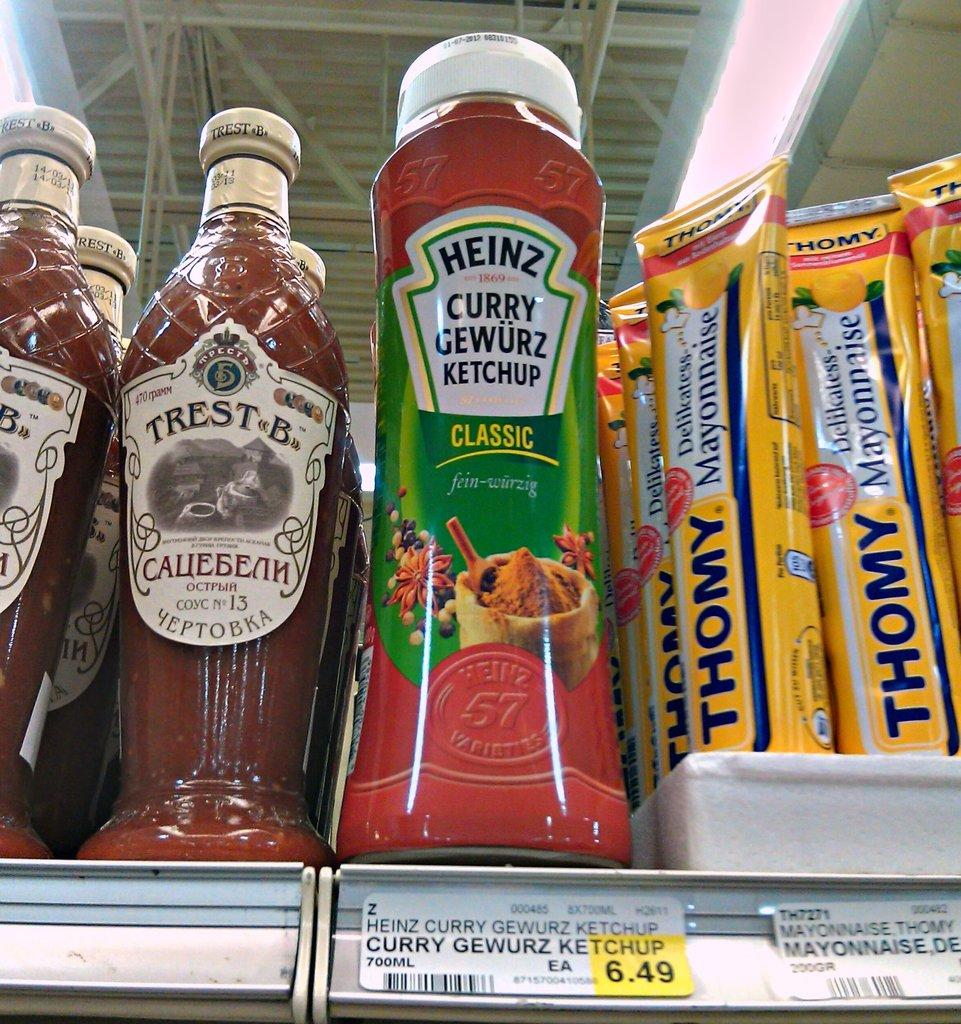Provide a one-sentence caption for the provided image. A bottle of ketchup has a price tag of 6.49. 